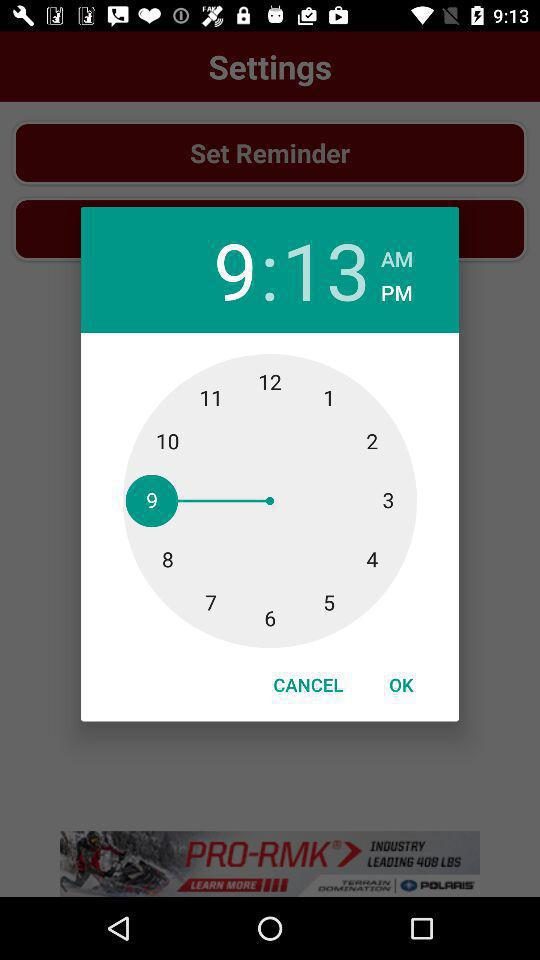How many more times does the number 3 appear than the number 4?
Answer the question using a single word or phrase. 1 